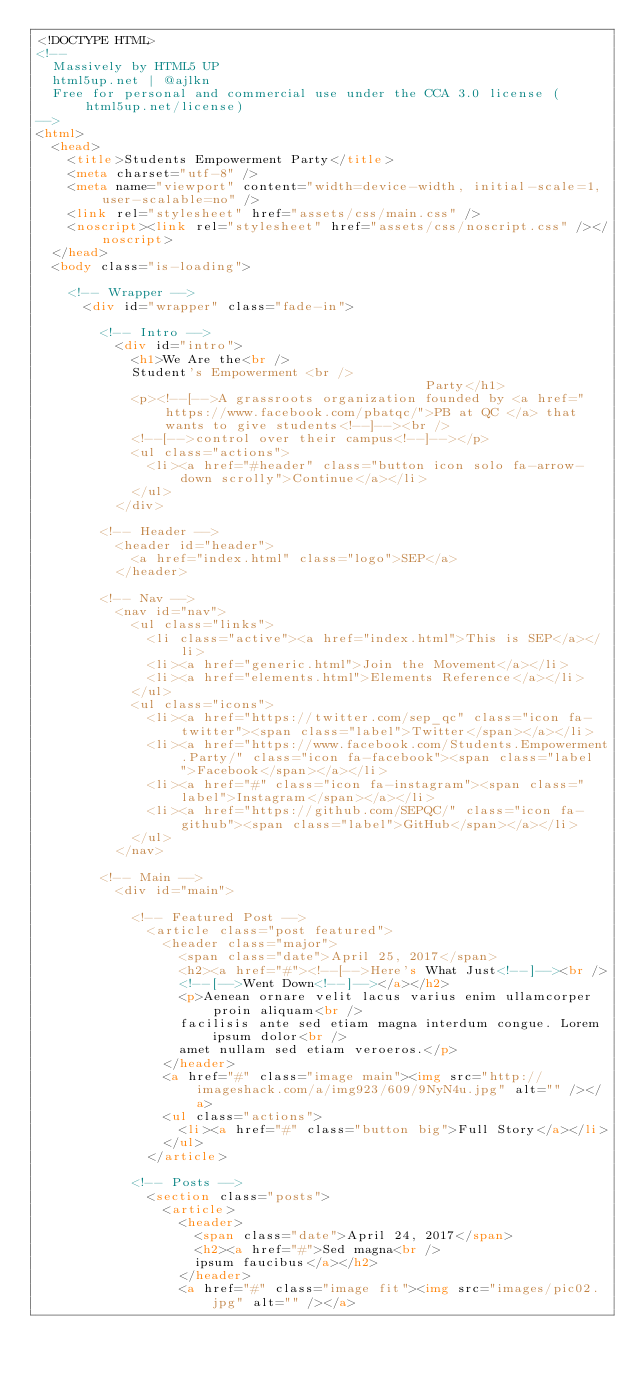<code> <loc_0><loc_0><loc_500><loc_500><_HTML_><!DOCTYPE HTML>
<!--
	Massively by HTML5 UP
	html5up.net | @ajlkn
	Free for personal and commercial use under the CCA 3.0 license (html5up.net/license)
-->
<html>
	<head>
		<title>Students Empowerment Party</title>
		<meta charset="utf-8" />
		<meta name="viewport" content="width=device-width, initial-scale=1, user-scalable=no" />
		<link rel="stylesheet" href="assets/css/main.css" />
		<noscript><link rel="stylesheet" href="assets/css/noscript.css" /></noscript>
	</head>
	<body class="is-loading">

		<!-- Wrapper -->
			<div id="wrapper" class="fade-in">

				<!-- Intro -->
					<div id="intro">
						<h1>We Are the<br />
						Student's Empowerment <br />
                                                 Party</h1>
						<p><!--[-->A grassroots organization founded by <a href="https://www.facebook.com/pbatqc/">PB at QC </a> that wants to give students<!--]--><br />
						<!--[-->control over their campus<!--]--></p>
						<ul class="actions">
							<li><a href="#header" class="button icon solo fa-arrow-down scrolly">Continue</a></li>
						</ul>
					</div>

				<!-- Header -->
					<header id="header">
						<a href="index.html" class="logo">SEP</a>
					</header>

				<!-- Nav -->
					<nav id="nav">
						<ul class="links">
							<li class="active"><a href="index.html">This is SEP</a></li>
							<li><a href="generic.html">Join the Movement</a></li>
							<li><a href="elements.html">Elements Reference</a></li>
						</ul>
						<ul class="icons">
							<li><a href="https://twitter.com/sep_qc" class="icon fa-twitter"><span class="label">Twitter</span></a></li>
							<li><a href="https://www.facebook.com/Students.Empowerment.Party/" class="icon fa-facebook"><span class="label">Facebook</span></a></li>
							<li><a href="#" class="icon fa-instagram"><span class="label">Instagram</span></a></li>
							<li><a href="https://github.com/SEPQC/" class="icon fa-github"><span class="label">GitHub</span></a></li>
						</ul>
					</nav>

				<!-- Main -->
					<div id="main">

						<!-- Featured Post -->
							<article class="post featured">
								<header class="major">
									<span class="date">April 25, 2017</span>
									<h2><a href="#"><!--[-->Here's What Just<!--]--><br />
									<!--[-->Went Down<!--]--></a></h2>
									<p>Aenean ornare velit lacus varius enim ullamcorper proin aliquam<br />
									facilisis ante sed etiam magna interdum congue. Lorem ipsum dolor<br />
									amet nullam sed etiam veroeros.</p>
								</header>
								<a href="#" class="image main"><img src="http://imageshack.com/a/img923/609/9NyN4u.jpg" alt="" /></a>
								<ul class="actions">
									<li><a href="#" class="button big">Full Story</a></li>
								</ul>
							</article>

						<!-- Posts -->
							<section class="posts">
								<article>
									<header>
										<span class="date">April 24, 2017</span>
										<h2><a href="#">Sed magna<br />
										ipsum faucibus</a></h2>
									</header>
									<a href="#" class="image fit"><img src="images/pic02.jpg" alt="" /></a></code> 